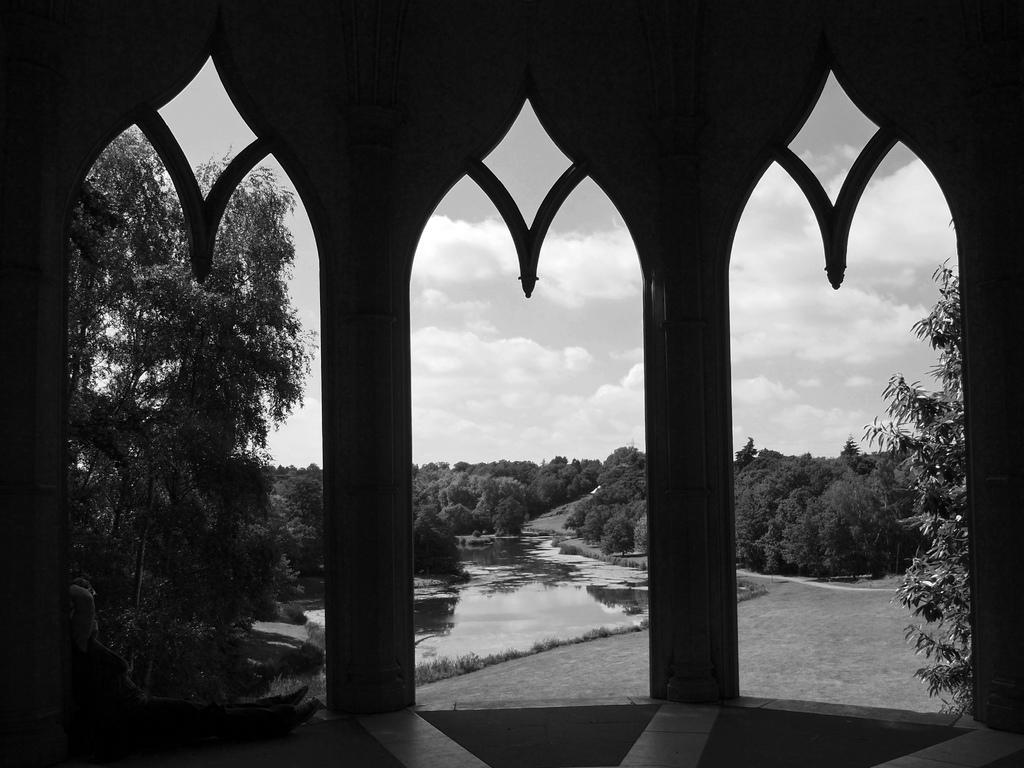Could you give a brief overview of what you see in this image? In the image we can see a shed. Through the shed we can see some trees and water and clouds and sky. 